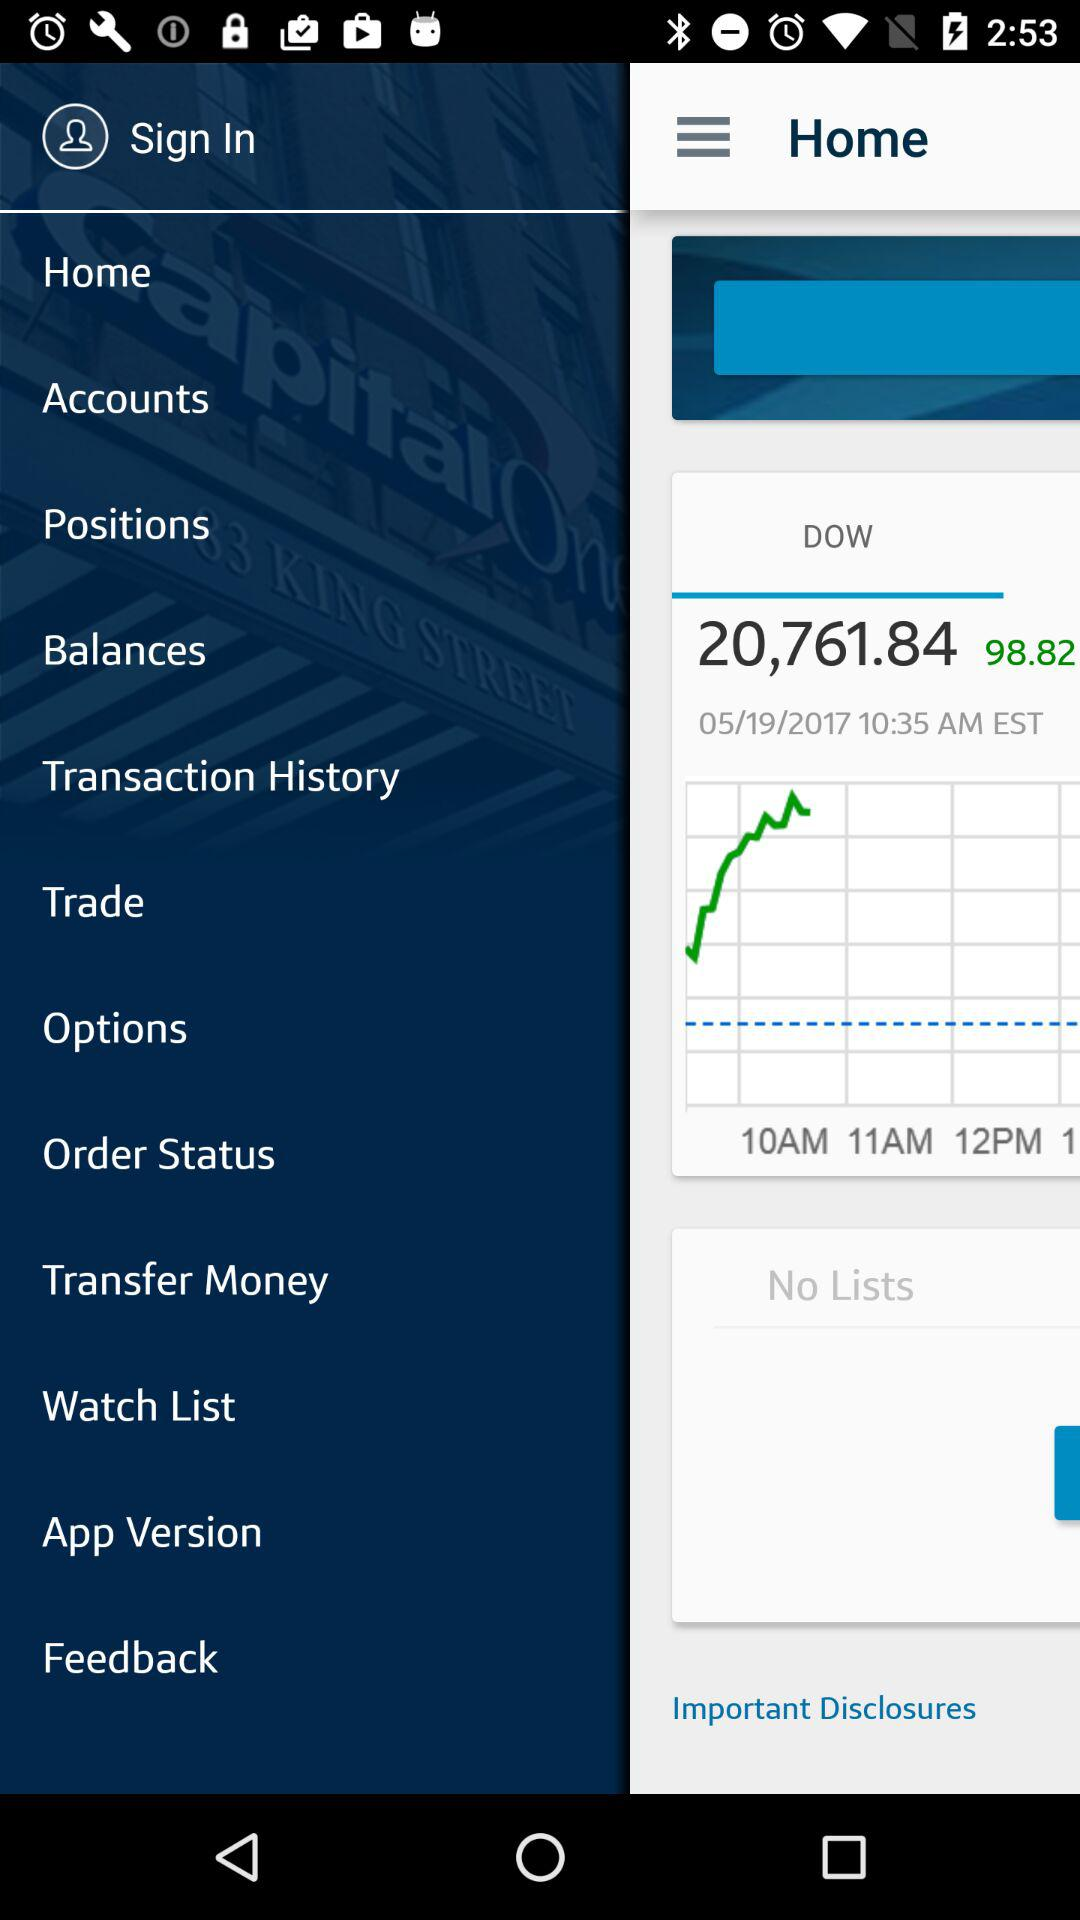What is the total amount of money in my account?
Answer the question using a single word or phrase. 20,761.84 